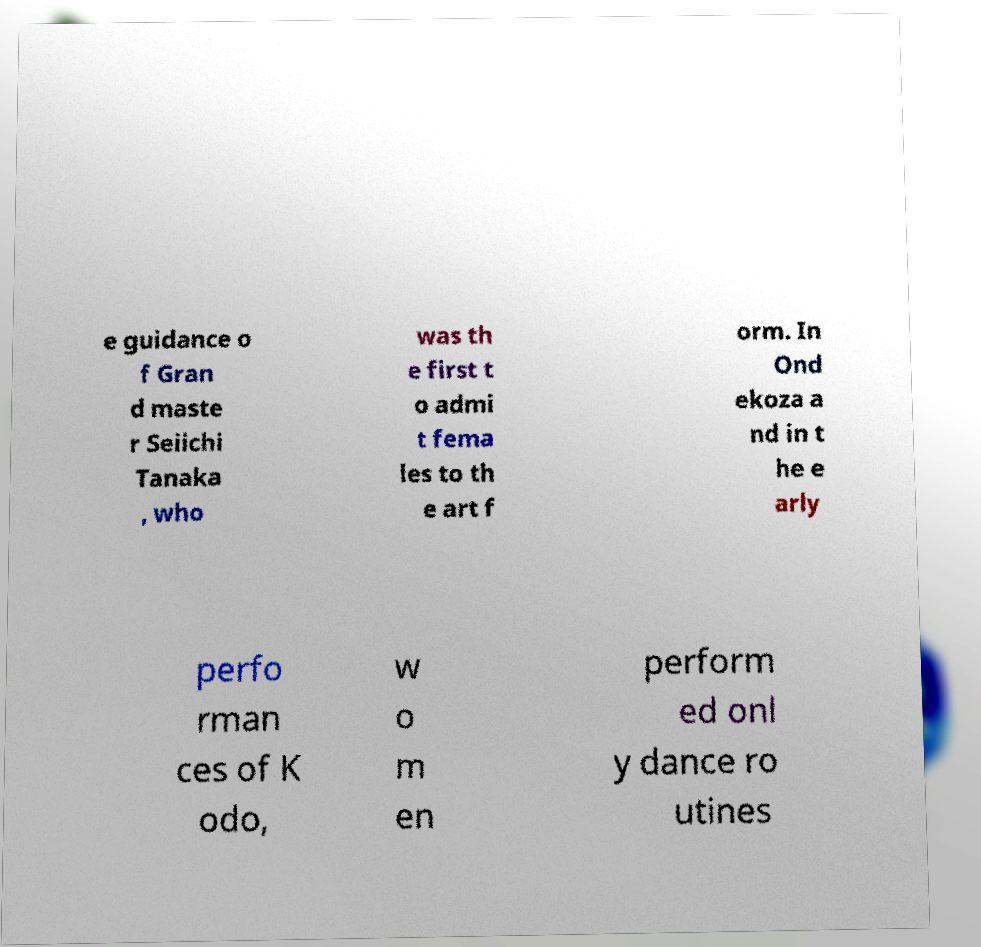Please read and relay the text visible in this image. What does it say? e guidance o f Gran d maste r Seiichi Tanaka , who was th e first t o admi t fema les to th e art f orm. In Ond ekoza a nd in t he e arly perfo rman ces of K odo, w o m en perform ed onl y dance ro utines 